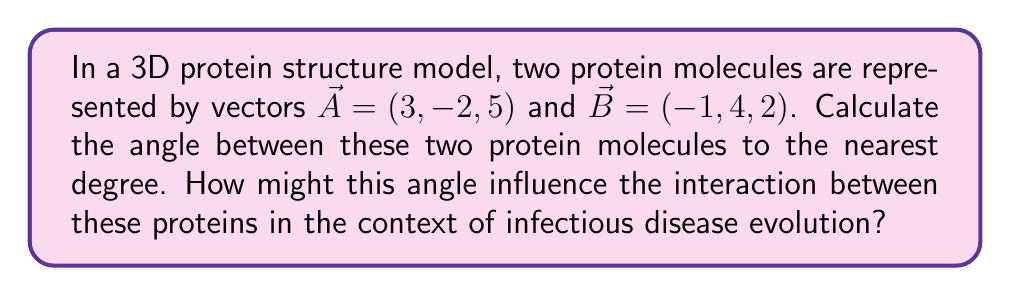Show me your answer to this math problem. To find the angle between two vectors in 3D space, we can use the dot product formula:

$$\cos \theta = \frac{\vec{A} \cdot \vec{B}}{|\vec{A}||\vec{B}|}$$

Where $\theta$ is the angle between the vectors, $\vec{A} \cdot \vec{B}$ is the dot product, and $|\vec{A}|$ and $|\vec{B}|$ are the magnitudes of vectors $\vec{A}$ and $\vec{B}$ respectively.

Step 1: Calculate the dot product $\vec{A} \cdot \vec{B}$
$$\vec{A} \cdot \vec{B} = (3)(-1) + (-2)(4) + (5)(2) = -3 - 8 + 10 = -1$$

Step 2: Calculate the magnitudes of $\vec{A}$ and $\vec{B}$
$$|\vec{A}| = \sqrt{3^2 + (-2)^2 + 5^2} = \sqrt{9 + 4 + 25} = \sqrt{38}$$
$$|\vec{B}| = \sqrt{(-1)^2 + 4^2 + 2^2} = \sqrt{1 + 16 + 4} = \sqrt{21}$$

Step 3: Substitute into the dot product formula
$$\cos \theta = \frac{-1}{\sqrt{38} \cdot \sqrt{21}}$$

Step 4: Solve for $\theta$ using inverse cosine (arccos)
$$\theta = \arccos\left(\frac{-1}{\sqrt{38} \cdot \sqrt{21}}\right)$$

Step 5: Calculate the result and round to the nearest degree
$$\theta \approx 93°$$

In the context of infectious disease evolution, this angle could significantly influence protein-protein interactions. A 93° angle suggests that the proteins are nearly perpendicular to each other, which might affect binding affinity, enzymatic activity, or the formation of protein complexes. These factors could impact viral replication, host cell entry, or immune system evasion, all of which are crucial in the evolution of infectious disease strains.
Answer: The angle between the two protein molecules is approximately 93°. 